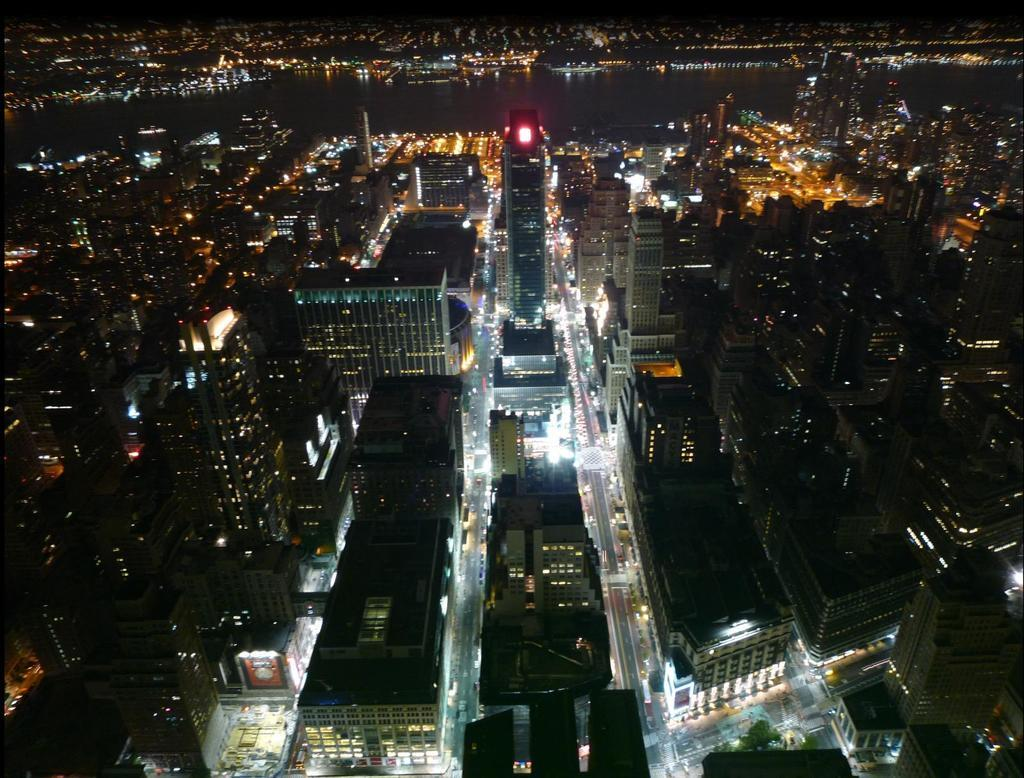What is the setting of the image? The image is a night view of a city. What structures can be seen in the image? There are many buildings in the image. What type of transportation infrastructure is visible in the image? There are roads visible in the image. What mode of transportation can be seen in the image? Vehicles are present in the image. What natural feature is present in the image? There is a river at the center of the buildings. What type of string is being used to hold up the buildings in the image? There is no string visible in the image, and the buildings are not being held up by any visible means. Can you see any porters carrying luggage in the image? There is no indication of porters or luggage in the image. 